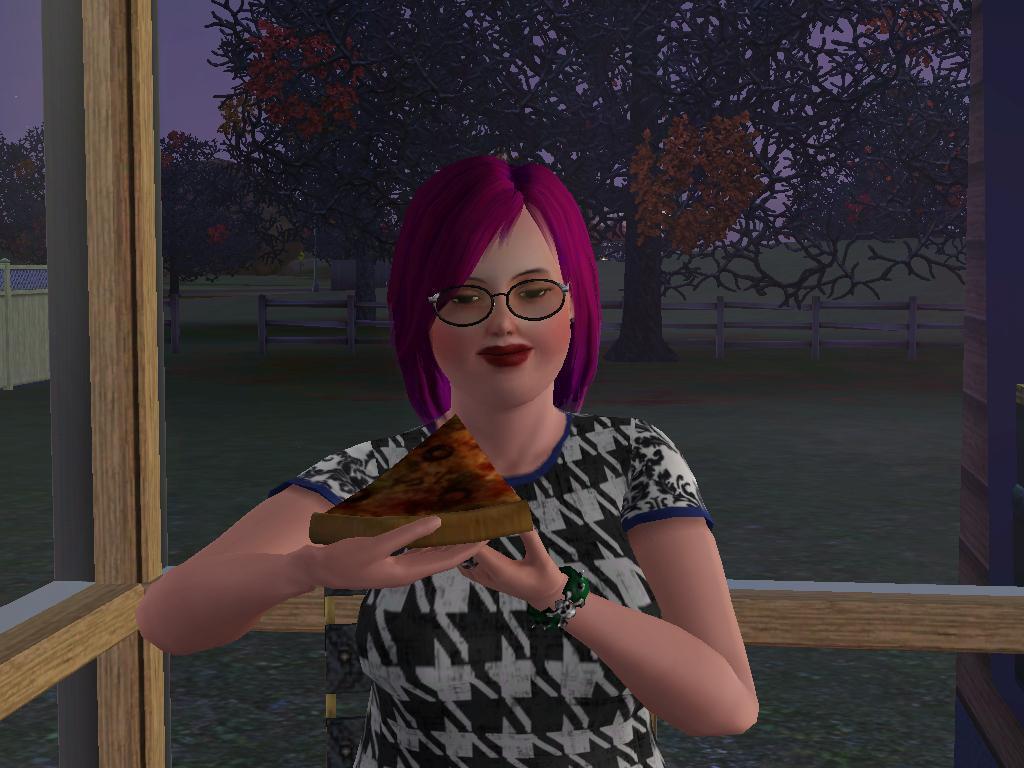Describe this image in one or two sentences. In the image there is an animated image of a woman, she is holding a pizza slice and behind the woman there are windows and behind those windows there is a tree. 